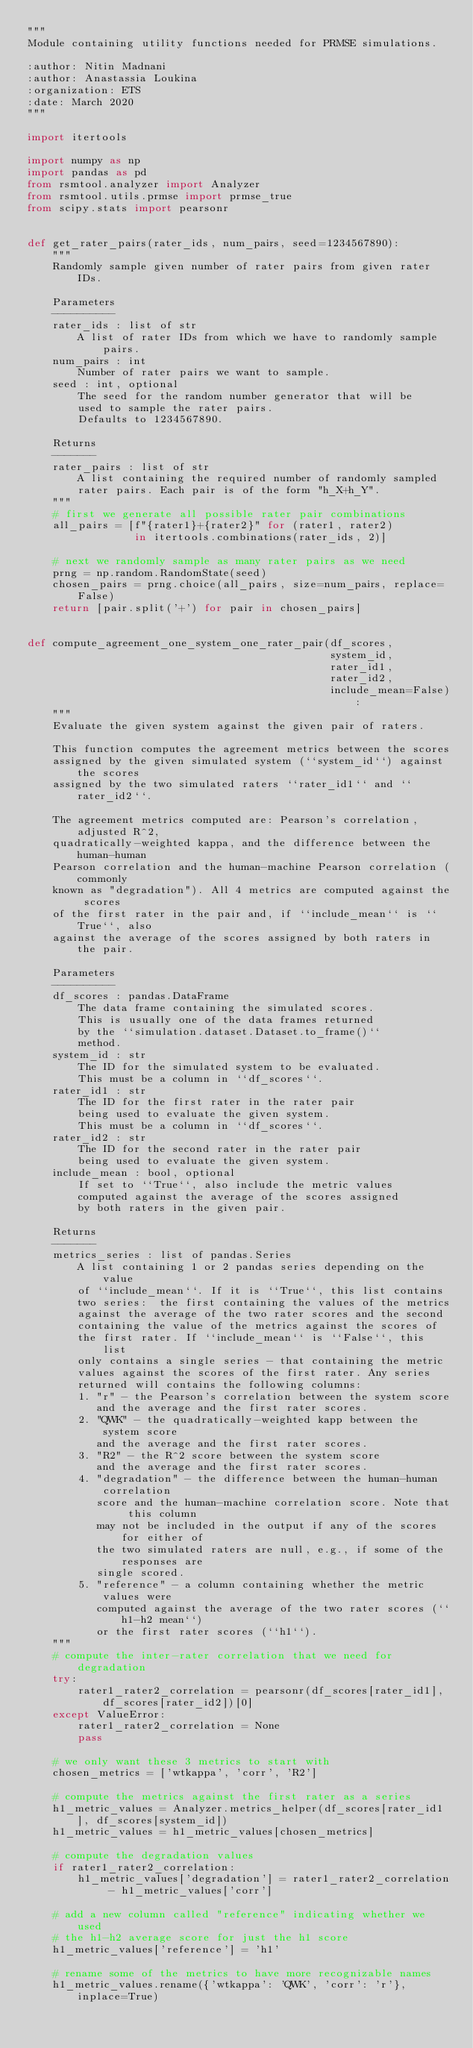Convert code to text. <code><loc_0><loc_0><loc_500><loc_500><_Python_>"""
Module containing utility functions needed for PRMSE simulations.

:author: Nitin Madnani
:author: Anastassia Loukina
:organization: ETS
:date: March 2020
"""

import itertools

import numpy as np
import pandas as pd
from rsmtool.analyzer import Analyzer
from rsmtool.utils.prmse import prmse_true
from scipy.stats import pearsonr


def get_rater_pairs(rater_ids, num_pairs, seed=1234567890):
    """
    Randomly sample given number of rater pairs from given rater IDs.

    Parameters
    ----------
    rater_ids : list of str
        A list of rater IDs from which we have to randomly sample pairs.
    num_pairs : int
        Number of rater pairs we want to sample.
    seed : int, optional
        The seed for the random number generator that will be
        used to sample the rater pairs.
        Defaults to 1234567890.

    Returns
    -------
    rater_pairs : list of str
        A list containing the required number of randomly sampled
        rater pairs. Each pair is of the form "h_X+h_Y".
    """
    # first we generate all possible rater pair combinations
    all_pairs = [f"{rater1}+{rater2}" for (rater1, rater2)
                 in itertools.combinations(rater_ids, 2)]

    # next we randomly sample as many rater pairs as we need
    prng = np.random.RandomState(seed)
    chosen_pairs = prng.choice(all_pairs, size=num_pairs, replace=False)
    return [pair.split('+') for pair in chosen_pairs]


def compute_agreement_one_system_one_rater_pair(df_scores,
                                                system_id,
                                                rater_id1,
                                                rater_id2,
                                                include_mean=False):
    """
    Evaluate the given system against the given pair of raters.

    This function computes the agreement metrics between the scores
    assigned by the given simulated system (``system_id``) against the scores
    assigned by the two simulated raters ``rater_id1`` and ``rater_id2``.

    The agreement metrics computed are: Pearson's correlation, adjusted R^2,
    quadratically-weighted kappa, and the difference between the human-human
    Pearson correlation and the human-machine Pearson correlation (commonly
    known as "degradation"). All 4 metrics are computed against the scores
    of the first rater in the pair and, if ``include_mean`` is ``True``, also
    against the average of the scores assigned by both raters in the pair.

    Parameters
    ----------
    df_scores : pandas.DataFrame
        The data frame containing the simulated scores.
        This is usually one of the data frames returned
        by the ``simulation.dataset.Dataset.to_frame()``
        method.
    system_id : str
        The ID for the simulated system to be evaluated.
        This must be a column in ``df_scores``.
    rater_id1 : str
        The ID for the first rater in the rater pair
        being used to evaluate the given system.
        This must be a column in ``df_scores``.
    rater_id2 : str
        The ID for the second rater in the rater pair
        being used to evaluate the given system.
    include_mean : bool, optional
        If set to ``True``, also include the metric values
        computed against the average of the scores assigned
        by both raters in the given pair.

    Returns
    -------
    metrics_series : list of pandas.Series
        A list containing 1 or 2 pandas series depending on the value
        of ``include_mean``. If it is ``True``, this list contains
        two series:  the first containing the values of the metrics
        against the average of the two rater scores and the second
        containing the value of the metrics against the scores of
        the first rater. If ``include_mean`` is ``False``, this list
        only contains a single series - that containing the metric
        values against the scores of the first rater. Any series
        returned will contains the following columns:
        1. "r" - the Pearson's correlation between the system score
           and the average and the first rater scores.
        2. "QWK" - the quadratically-weighted kapp between the system score
           and the average and the first rater scores.
        3. "R2" - the R^2 score between the system score
           and the average and the first rater scores.
        4. "degradation" - the difference between the human-human correlation
           score and the human-machine correlation score. Note that this column
           may not be included in the output if any of the scores for either of
           the two simulated raters are null, e.g., if some of the responses are
           single scored.
        5. "reference" - a column containing whether the metric values were
           computed against the average of the two rater scores (``h1-h2 mean``)
           or the first rater scores (``h1``).
    """
    # compute the inter-rater correlation that we need for degradation
    try:
        rater1_rater2_correlation = pearsonr(df_scores[rater_id1], df_scores[rater_id2])[0]
    except ValueError:
        rater1_rater2_correlation = None
        pass

    # we only want these 3 metrics to start with
    chosen_metrics = ['wtkappa', 'corr', 'R2']

    # compute the metrics against the first rater as a series
    h1_metric_values = Analyzer.metrics_helper(df_scores[rater_id1], df_scores[system_id])
    h1_metric_values = h1_metric_values[chosen_metrics]

    # compute the degradation values
    if rater1_rater2_correlation:
        h1_metric_values['degradation'] = rater1_rater2_correlation - h1_metric_values['corr']

    # add a new column called "reference" indicating whether we used
    # the h1-h2 average score for just the h1 score
    h1_metric_values['reference'] = 'h1'

    # rename some of the metrics to have more recognizable names
    h1_metric_values.rename({'wtkappa': 'QWK', 'corr': 'r'}, inplace=True)
</code> 